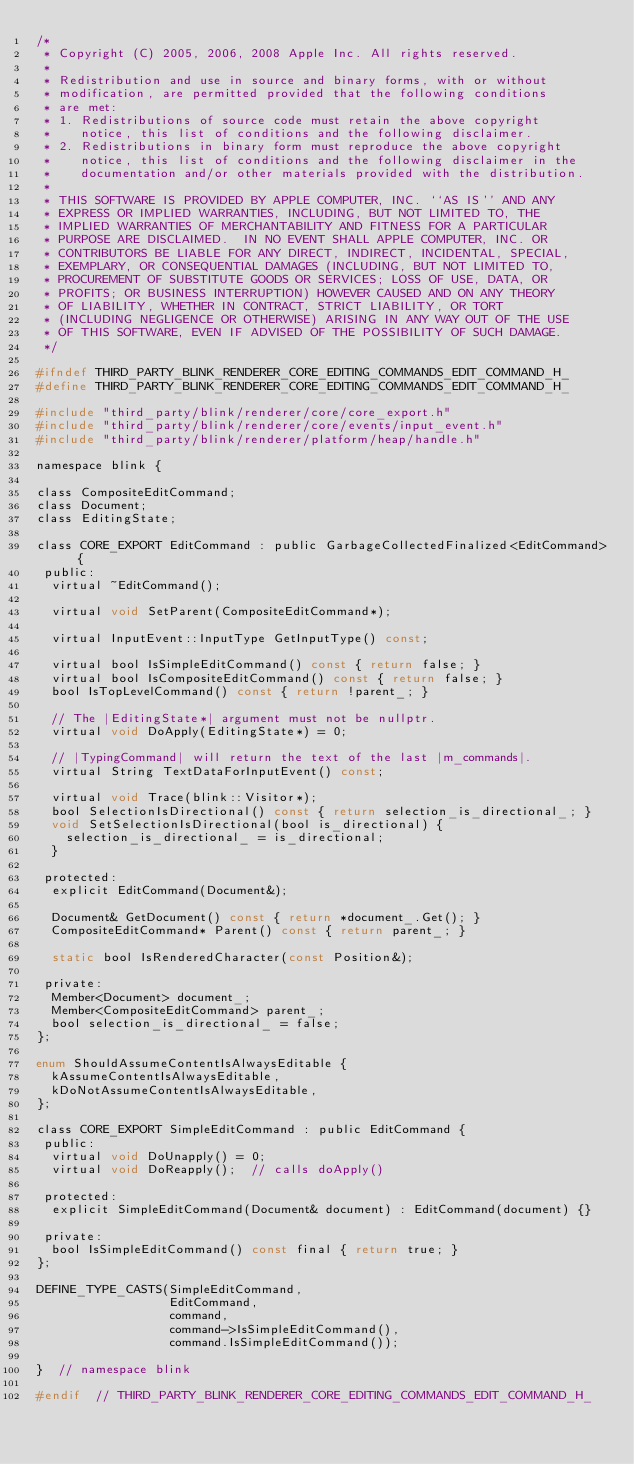<code> <loc_0><loc_0><loc_500><loc_500><_C_>/*
 * Copyright (C) 2005, 2006, 2008 Apple Inc. All rights reserved.
 *
 * Redistribution and use in source and binary forms, with or without
 * modification, are permitted provided that the following conditions
 * are met:
 * 1. Redistributions of source code must retain the above copyright
 *    notice, this list of conditions and the following disclaimer.
 * 2. Redistributions in binary form must reproduce the above copyright
 *    notice, this list of conditions and the following disclaimer in the
 *    documentation and/or other materials provided with the distribution.
 *
 * THIS SOFTWARE IS PROVIDED BY APPLE COMPUTER, INC. ``AS IS'' AND ANY
 * EXPRESS OR IMPLIED WARRANTIES, INCLUDING, BUT NOT LIMITED TO, THE
 * IMPLIED WARRANTIES OF MERCHANTABILITY AND FITNESS FOR A PARTICULAR
 * PURPOSE ARE DISCLAIMED.  IN NO EVENT SHALL APPLE COMPUTER, INC. OR
 * CONTRIBUTORS BE LIABLE FOR ANY DIRECT, INDIRECT, INCIDENTAL, SPECIAL,
 * EXEMPLARY, OR CONSEQUENTIAL DAMAGES (INCLUDING, BUT NOT LIMITED TO,
 * PROCUREMENT OF SUBSTITUTE GOODS OR SERVICES; LOSS OF USE, DATA, OR
 * PROFITS; OR BUSINESS INTERRUPTION) HOWEVER CAUSED AND ON ANY THEORY
 * OF LIABILITY, WHETHER IN CONTRACT, STRICT LIABILITY, OR TORT
 * (INCLUDING NEGLIGENCE OR OTHERWISE) ARISING IN ANY WAY OUT OF THE USE
 * OF THIS SOFTWARE, EVEN IF ADVISED OF THE POSSIBILITY OF SUCH DAMAGE.
 */

#ifndef THIRD_PARTY_BLINK_RENDERER_CORE_EDITING_COMMANDS_EDIT_COMMAND_H_
#define THIRD_PARTY_BLINK_RENDERER_CORE_EDITING_COMMANDS_EDIT_COMMAND_H_

#include "third_party/blink/renderer/core/core_export.h"
#include "third_party/blink/renderer/core/events/input_event.h"
#include "third_party/blink/renderer/platform/heap/handle.h"

namespace blink {

class CompositeEditCommand;
class Document;
class EditingState;

class CORE_EXPORT EditCommand : public GarbageCollectedFinalized<EditCommand> {
 public:
  virtual ~EditCommand();

  virtual void SetParent(CompositeEditCommand*);

  virtual InputEvent::InputType GetInputType() const;

  virtual bool IsSimpleEditCommand() const { return false; }
  virtual bool IsCompositeEditCommand() const { return false; }
  bool IsTopLevelCommand() const { return !parent_; }

  // The |EditingState*| argument must not be nullptr.
  virtual void DoApply(EditingState*) = 0;

  // |TypingCommand| will return the text of the last |m_commands|.
  virtual String TextDataForInputEvent() const;

  virtual void Trace(blink::Visitor*);
  bool SelectionIsDirectional() const { return selection_is_directional_; }
  void SetSelectionIsDirectional(bool is_directional) {
    selection_is_directional_ = is_directional;
  }

 protected:
  explicit EditCommand(Document&);

  Document& GetDocument() const { return *document_.Get(); }
  CompositeEditCommand* Parent() const { return parent_; }

  static bool IsRenderedCharacter(const Position&);

 private:
  Member<Document> document_;
  Member<CompositeEditCommand> parent_;
  bool selection_is_directional_ = false;
};

enum ShouldAssumeContentIsAlwaysEditable {
  kAssumeContentIsAlwaysEditable,
  kDoNotAssumeContentIsAlwaysEditable,
};

class CORE_EXPORT SimpleEditCommand : public EditCommand {
 public:
  virtual void DoUnapply() = 0;
  virtual void DoReapply();  // calls doApply()

 protected:
  explicit SimpleEditCommand(Document& document) : EditCommand(document) {}

 private:
  bool IsSimpleEditCommand() const final { return true; }
};

DEFINE_TYPE_CASTS(SimpleEditCommand,
                  EditCommand,
                  command,
                  command->IsSimpleEditCommand(),
                  command.IsSimpleEditCommand());

}  // namespace blink

#endif  // THIRD_PARTY_BLINK_RENDERER_CORE_EDITING_COMMANDS_EDIT_COMMAND_H_
</code> 